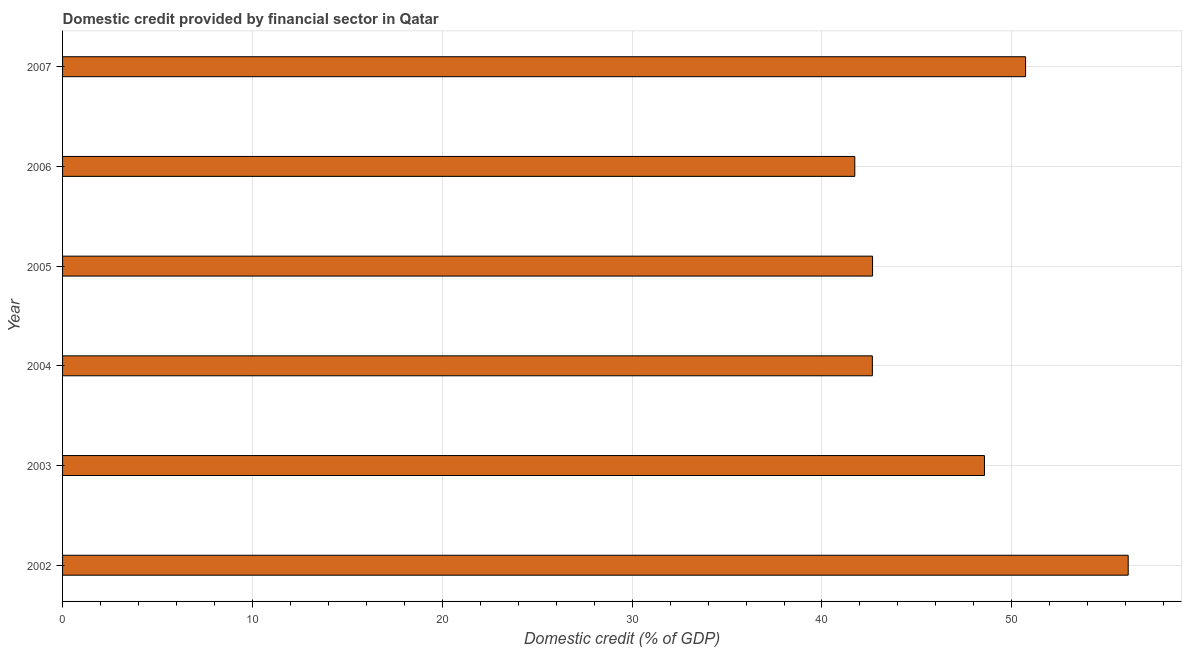Does the graph contain any zero values?
Provide a short and direct response. No. What is the title of the graph?
Your response must be concise. Domestic credit provided by financial sector in Qatar. What is the label or title of the X-axis?
Keep it short and to the point. Domestic credit (% of GDP). What is the domestic credit provided by financial sector in 2005?
Offer a terse response. 42.66. Across all years, what is the maximum domestic credit provided by financial sector?
Your response must be concise. 56.13. Across all years, what is the minimum domestic credit provided by financial sector?
Offer a very short reply. 41.73. What is the sum of the domestic credit provided by financial sector?
Provide a succinct answer. 282.46. What is the difference between the domestic credit provided by financial sector in 2003 and 2004?
Your answer should be compact. 5.91. What is the average domestic credit provided by financial sector per year?
Keep it short and to the point. 47.08. What is the median domestic credit provided by financial sector?
Provide a short and direct response. 45.61. Do a majority of the years between 2003 and 2006 (inclusive) have domestic credit provided by financial sector greater than 12 %?
Your answer should be very brief. Yes. What is the ratio of the domestic credit provided by financial sector in 2004 to that in 2007?
Make the answer very short. 0.84. Is the difference between the domestic credit provided by financial sector in 2005 and 2006 greater than the difference between any two years?
Provide a succinct answer. No. What is the difference between the highest and the second highest domestic credit provided by financial sector?
Offer a terse response. 5.41. Is the sum of the domestic credit provided by financial sector in 2005 and 2007 greater than the maximum domestic credit provided by financial sector across all years?
Your answer should be very brief. Yes. What is the difference between the highest and the lowest domestic credit provided by financial sector?
Offer a very short reply. 14.4. In how many years, is the domestic credit provided by financial sector greater than the average domestic credit provided by financial sector taken over all years?
Provide a succinct answer. 3. Are all the bars in the graph horizontal?
Provide a short and direct response. Yes. How many years are there in the graph?
Give a very brief answer. 6. What is the difference between two consecutive major ticks on the X-axis?
Give a very brief answer. 10. Are the values on the major ticks of X-axis written in scientific E-notation?
Your response must be concise. No. What is the Domestic credit (% of GDP) of 2002?
Offer a very short reply. 56.13. What is the Domestic credit (% of GDP) of 2003?
Your response must be concise. 48.56. What is the Domestic credit (% of GDP) in 2004?
Keep it short and to the point. 42.65. What is the Domestic credit (% of GDP) in 2005?
Ensure brevity in your answer.  42.66. What is the Domestic credit (% of GDP) of 2006?
Provide a short and direct response. 41.73. What is the Domestic credit (% of GDP) of 2007?
Offer a terse response. 50.72. What is the difference between the Domestic credit (% of GDP) in 2002 and 2003?
Offer a terse response. 7.57. What is the difference between the Domestic credit (% of GDP) in 2002 and 2004?
Your response must be concise. 13.48. What is the difference between the Domestic credit (% of GDP) in 2002 and 2005?
Make the answer very short. 13.47. What is the difference between the Domestic credit (% of GDP) in 2002 and 2006?
Offer a very short reply. 14.4. What is the difference between the Domestic credit (% of GDP) in 2002 and 2007?
Offer a very short reply. 5.4. What is the difference between the Domestic credit (% of GDP) in 2003 and 2004?
Ensure brevity in your answer.  5.9. What is the difference between the Domestic credit (% of GDP) in 2003 and 2005?
Provide a succinct answer. 5.89. What is the difference between the Domestic credit (% of GDP) in 2003 and 2006?
Make the answer very short. 6.83. What is the difference between the Domestic credit (% of GDP) in 2003 and 2007?
Your answer should be very brief. -2.17. What is the difference between the Domestic credit (% of GDP) in 2004 and 2005?
Offer a terse response. -0.01. What is the difference between the Domestic credit (% of GDP) in 2004 and 2006?
Offer a very short reply. 0.93. What is the difference between the Domestic credit (% of GDP) in 2004 and 2007?
Your answer should be compact. -8.07. What is the difference between the Domestic credit (% of GDP) in 2005 and 2006?
Make the answer very short. 0.94. What is the difference between the Domestic credit (% of GDP) in 2005 and 2007?
Your answer should be very brief. -8.06. What is the difference between the Domestic credit (% of GDP) in 2006 and 2007?
Offer a terse response. -9. What is the ratio of the Domestic credit (% of GDP) in 2002 to that in 2003?
Provide a succinct answer. 1.16. What is the ratio of the Domestic credit (% of GDP) in 2002 to that in 2004?
Your answer should be compact. 1.32. What is the ratio of the Domestic credit (% of GDP) in 2002 to that in 2005?
Offer a terse response. 1.32. What is the ratio of the Domestic credit (% of GDP) in 2002 to that in 2006?
Your response must be concise. 1.34. What is the ratio of the Domestic credit (% of GDP) in 2002 to that in 2007?
Your answer should be compact. 1.11. What is the ratio of the Domestic credit (% of GDP) in 2003 to that in 2004?
Ensure brevity in your answer.  1.14. What is the ratio of the Domestic credit (% of GDP) in 2003 to that in 2005?
Give a very brief answer. 1.14. What is the ratio of the Domestic credit (% of GDP) in 2003 to that in 2006?
Give a very brief answer. 1.16. What is the ratio of the Domestic credit (% of GDP) in 2003 to that in 2007?
Make the answer very short. 0.96. What is the ratio of the Domestic credit (% of GDP) in 2004 to that in 2005?
Offer a terse response. 1. What is the ratio of the Domestic credit (% of GDP) in 2004 to that in 2006?
Offer a terse response. 1.02. What is the ratio of the Domestic credit (% of GDP) in 2004 to that in 2007?
Ensure brevity in your answer.  0.84. What is the ratio of the Domestic credit (% of GDP) in 2005 to that in 2007?
Your answer should be compact. 0.84. What is the ratio of the Domestic credit (% of GDP) in 2006 to that in 2007?
Provide a succinct answer. 0.82. 